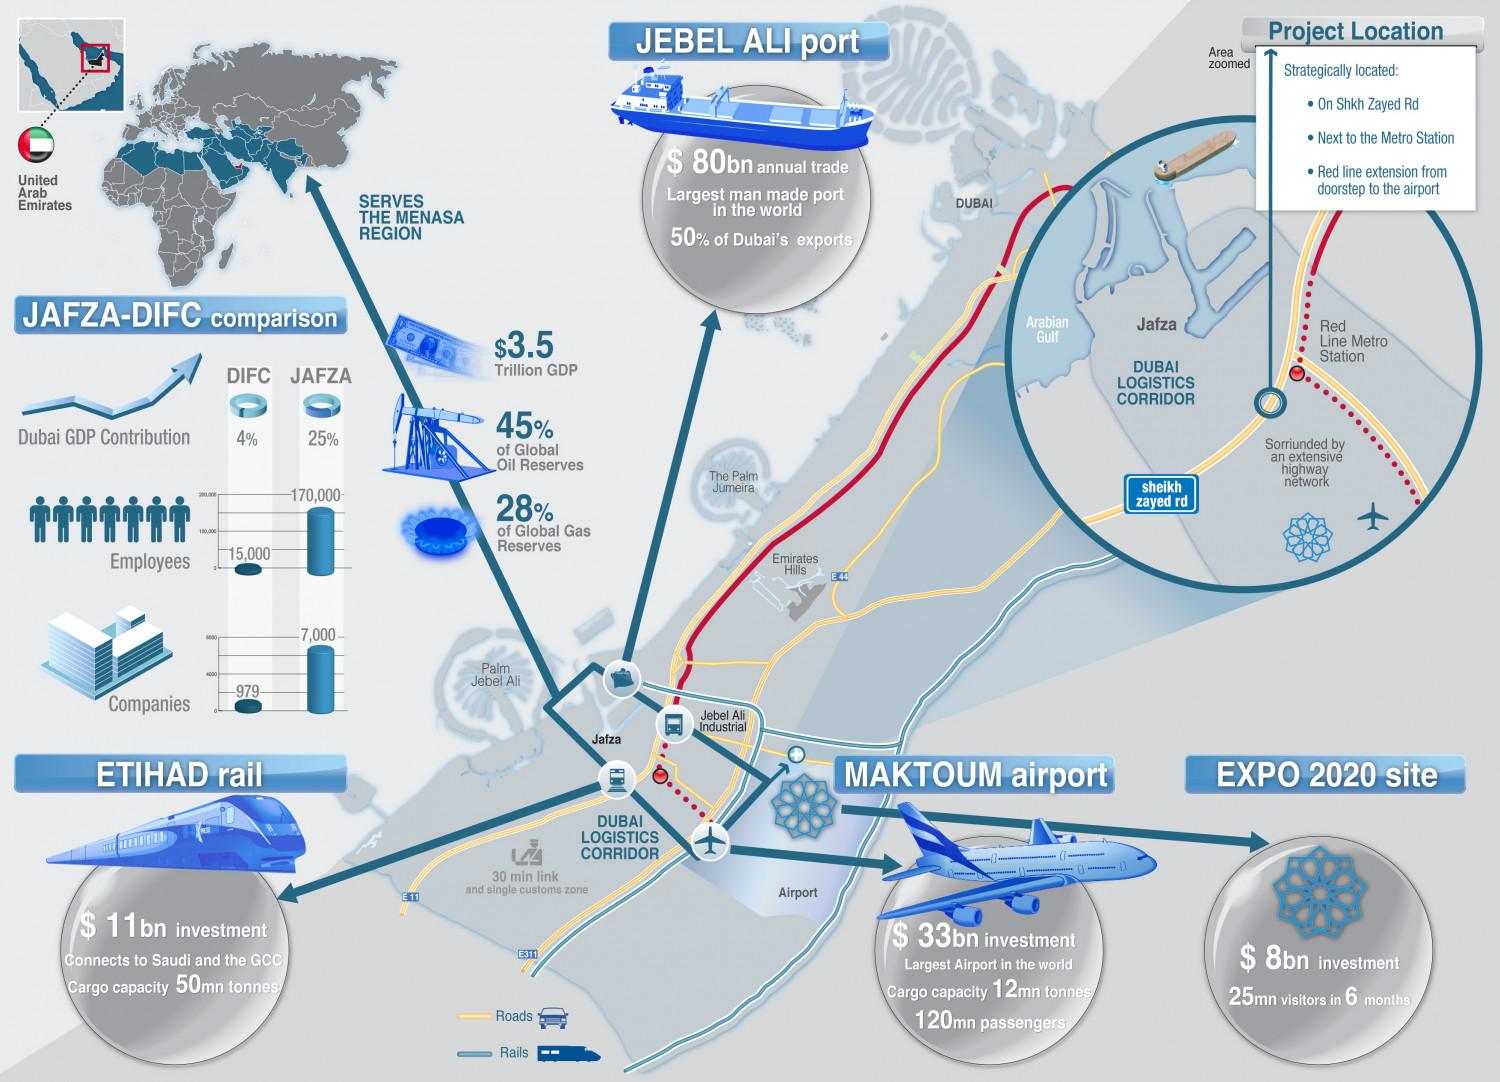Mention a couple of crucial points in this snapshot. The text "What is the difference between employees in JAFZA and IFC? 155000.." is a question asking for information about the differences between employees in JAFZA (Jebel Ali Free Zone Authority) and IFC (International Financial Center). The text contains a numerical value of 155000 which is not clear from the context. As of my knowledge cutoff date in 2021, the total number of companies registered in both JAFZA and IFC was 7,979. It is estimated that approximately 73% of the world's oil and gas reserves are currently in use. 